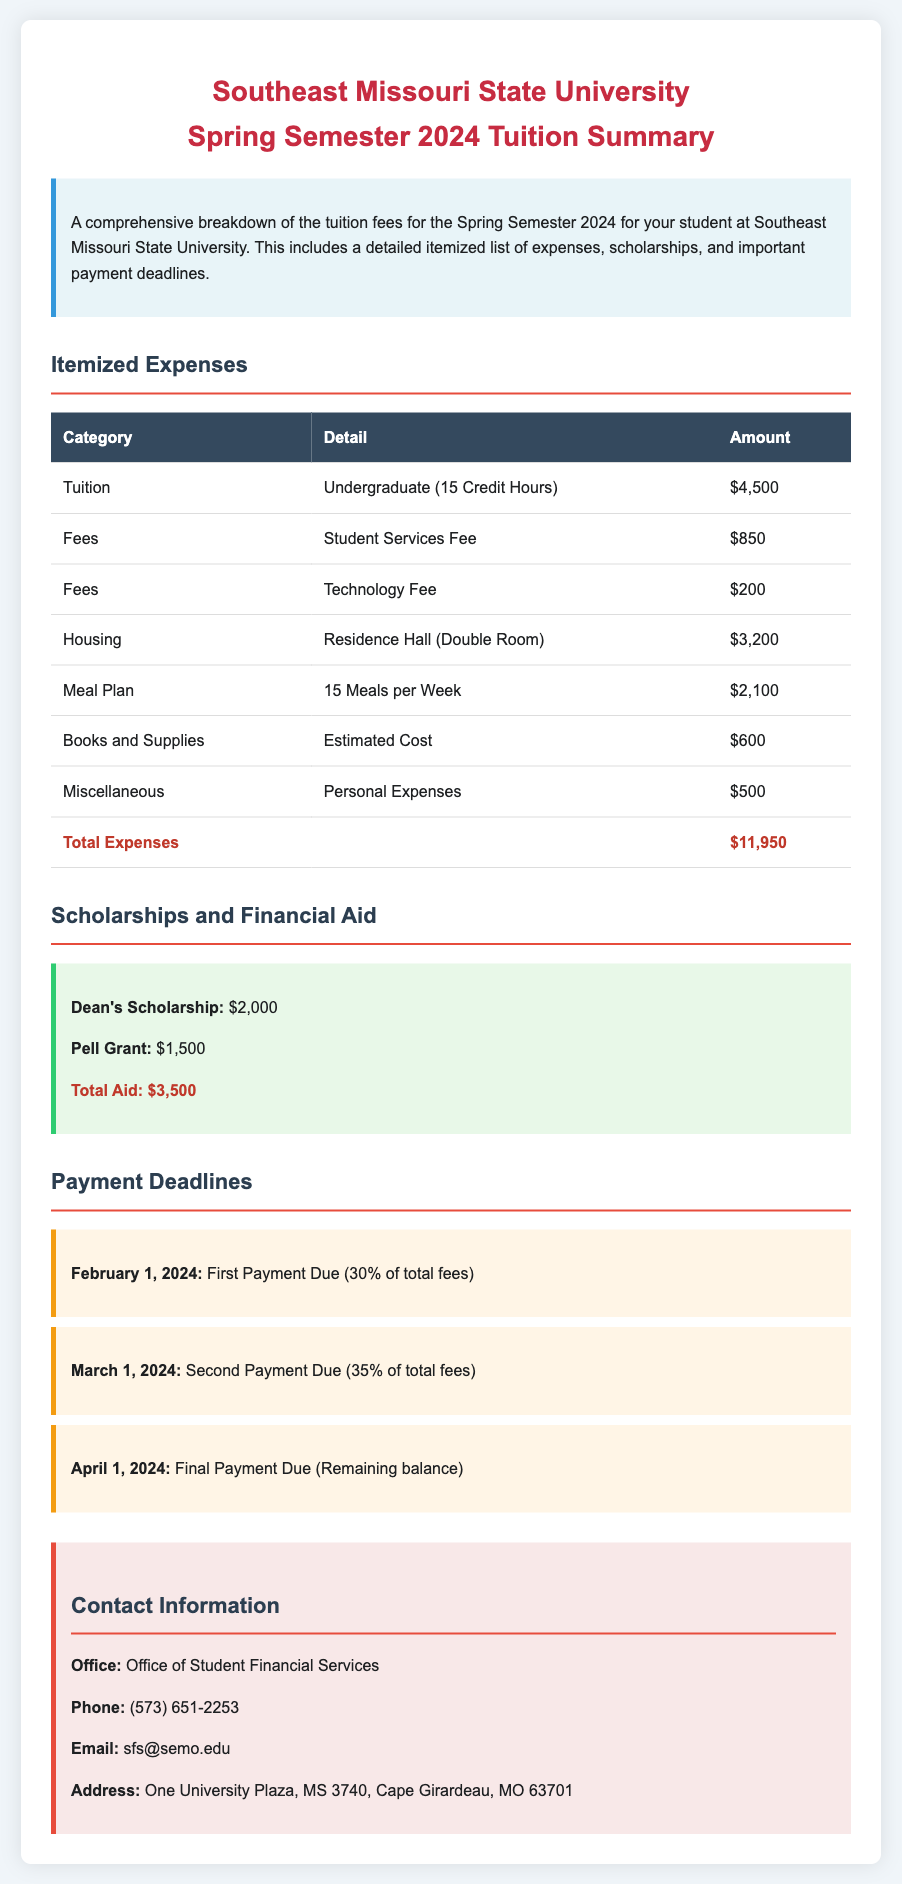What is the total tuition for the Spring Semester 2024? The total tuition is the amount listed under the tuition section for undergraduate students, which is $4,500.
Answer: $4,500 How much is the housing fee? The housing fee for a residence hall (double room) is provided in the itemized expenses section.
Answer: $3,200 What is the total amount of financial aid? The total aid is the sum of scholarships listed in the document, which is $2,000 + $1,500.
Answer: $3,500 When is the first payment due? The first payment deadline is mentioned in the payment deadlines section, which is on February 1, 2024.
Answer: February 1, 2024 What is included in the Meal Plan fee? The meal plan fee specifies the number of meals included for the week as part of the expenses.
Answer: 15 Meals per Week How much are miscellaneous expenses listed? The miscellaneous personal expenses are separately stated in the document.
Answer: $500 What percentage of total fees is due in the second payment? The percentage due for the second payment is described in the payment deadlines section.
Answer: 35% What type of scholarship is mentioned first? The first scholarship listed in the scholarships and financial aid section is identified.
Answer: Dean's Scholarship What is the contact email for student financial services? The contact information section provides the email address for the office of student financial services.
Answer: sfs@semo.edu 